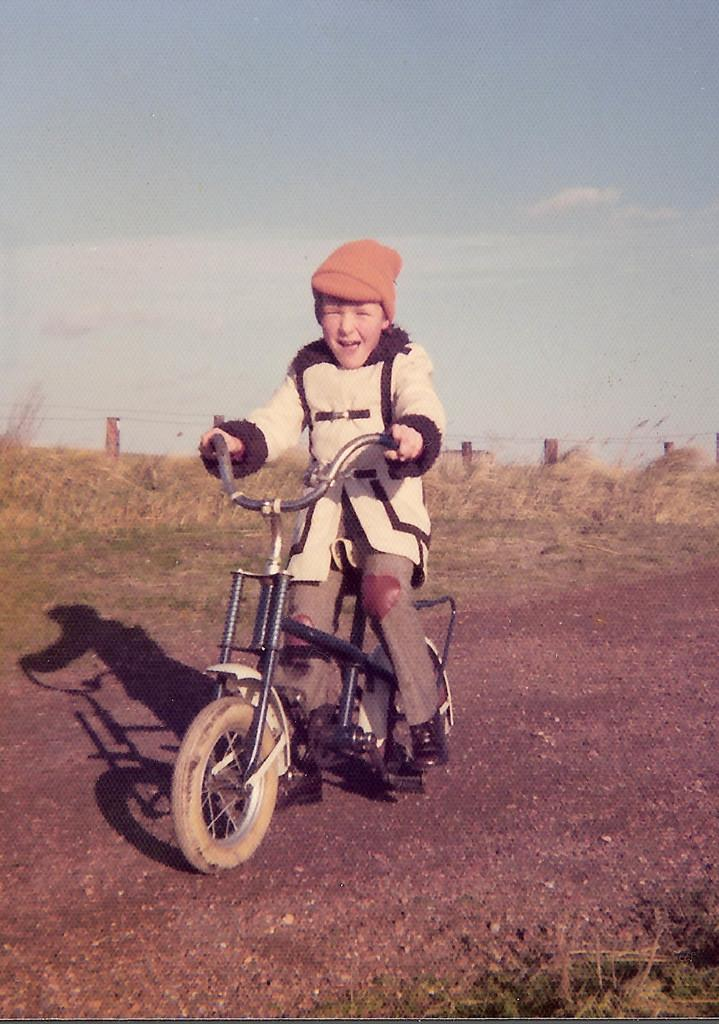Who is the main subject in the image? There is a boy in the image. What is the boy doing in the image? The boy is riding a bicycle. What is the position of the bicycle in the image? The bicycle is on the ground. What type of vegetation can be seen on the ground? There are plants and grass on the ground. What is visible at the top of the image? The sky is visible at the top of the image. What is the purpose of the camp in the image? There is no camp present in the image; it features a boy riding a bicycle. Can you tell me how many people are sleeping in the image? There are no people sleeping in the image; it shows a boy riding a bicycle. 